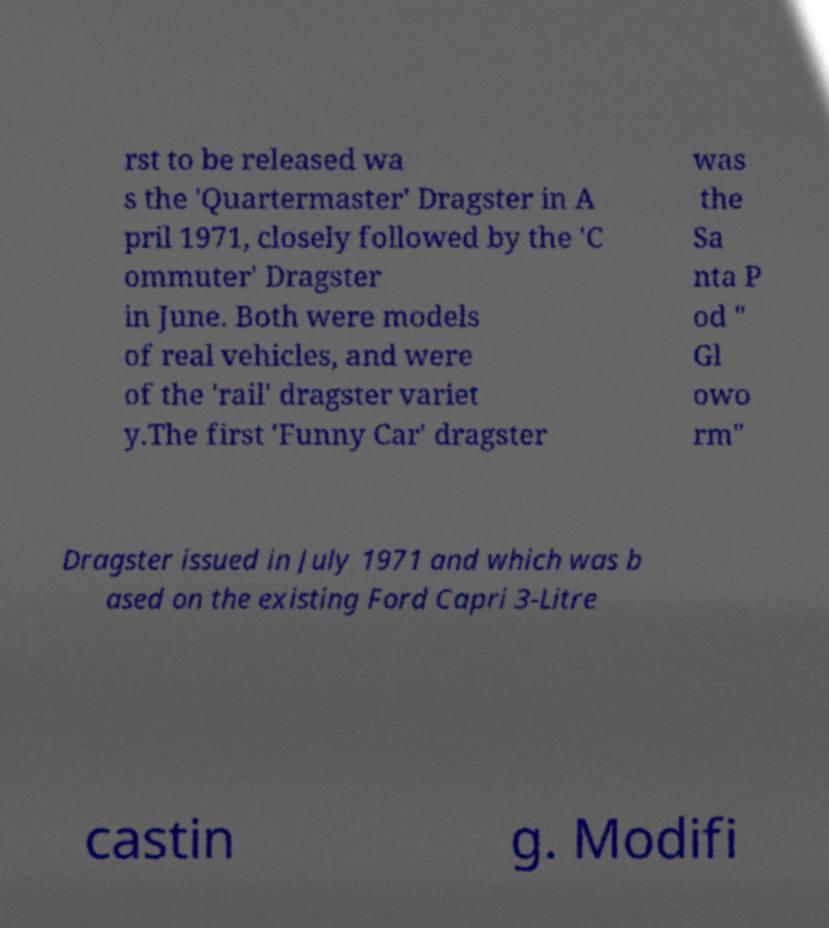I need the written content from this picture converted into text. Can you do that? rst to be released wa s the 'Quartermaster' Dragster in A pril 1971, closely followed by the 'C ommuter' Dragster in June. Both were models of real vehicles, and were of the 'rail' dragster variet y.The first 'Funny Car' dragster was the Sa nta P od " Gl owo rm" Dragster issued in July 1971 and which was b ased on the existing Ford Capri 3-Litre castin g. Modifi 